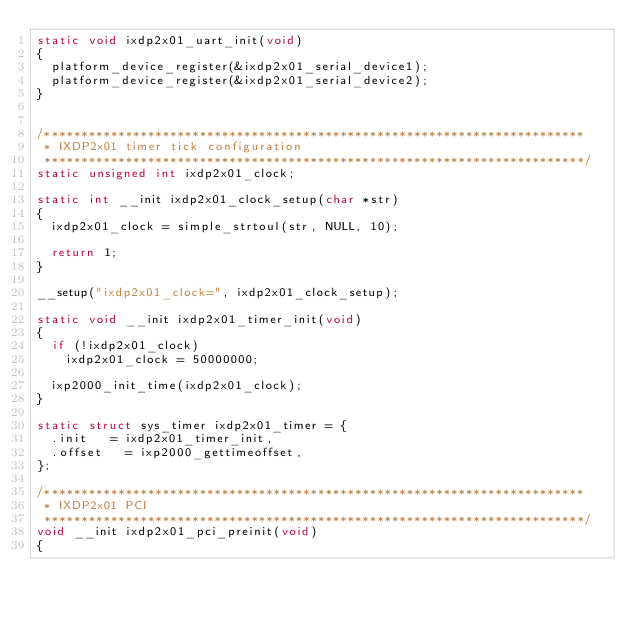Convert code to text. <code><loc_0><loc_0><loc_500><loc_500><_C_>static void ixdp2x01_uart_init(void)
{
	platform_device_register(&ixdp2x01_serial_device1);
	platform_device_register(&ixdp2x01_serial_device2);
}


/*************************************************************************
 * IXDP2x01 timer tick configuration
 *************************************************************************/
static unsigned int ixdp2x01_clock;

static int __init ixdp2x01_clock_setup(char *str)
{
	ixdp2x01_clock = simple_strtoul(str, NULL, 10);

	return 1;
}

__setup("ixdp2x01_clock=", ixdp2x01_clock_setup);

static void __init ixdp2x01_timer_init(void)
{
	if (!ixdp2x01_clock)
		ixdp2x01_clock = 50000000;

	ixp2000_init_time(ixdp2x01_clock);
}

static struct sys_timer ixdp2x01_timer = {
	.init		= ixdp2x01_timer_init,
	.offset		= ixp2000_gettimeoffset,
};

/*************************************************************************
 * IXDP2x01 PCI
 *************************************************************************/
void __init ixdp2x01_pci_preinit(void)
{</code> 